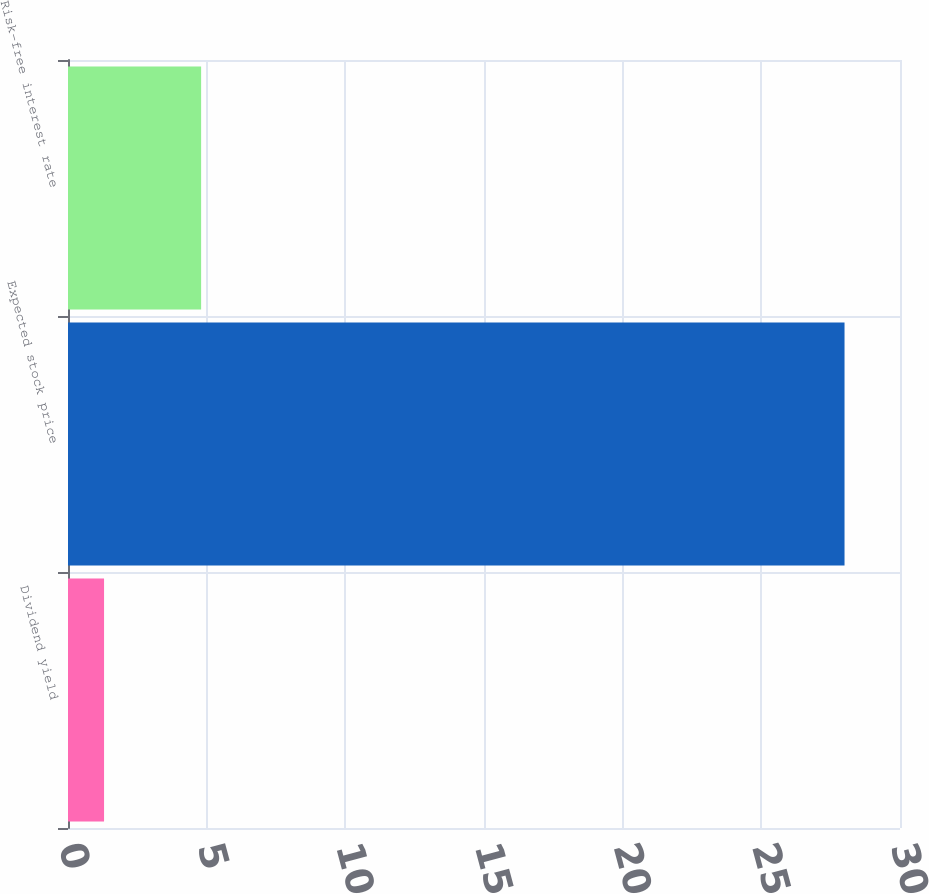Convert chart to OTSL. <chart><loc_0><loc_0><loc_500><loc_500><bar_chart><fcel>Dividend yield<fcel>Expected stock price<fcel>Risk-free interest rate<nl><fcel>1.3<fcel>28<fcel>4.8<nl></chart> 